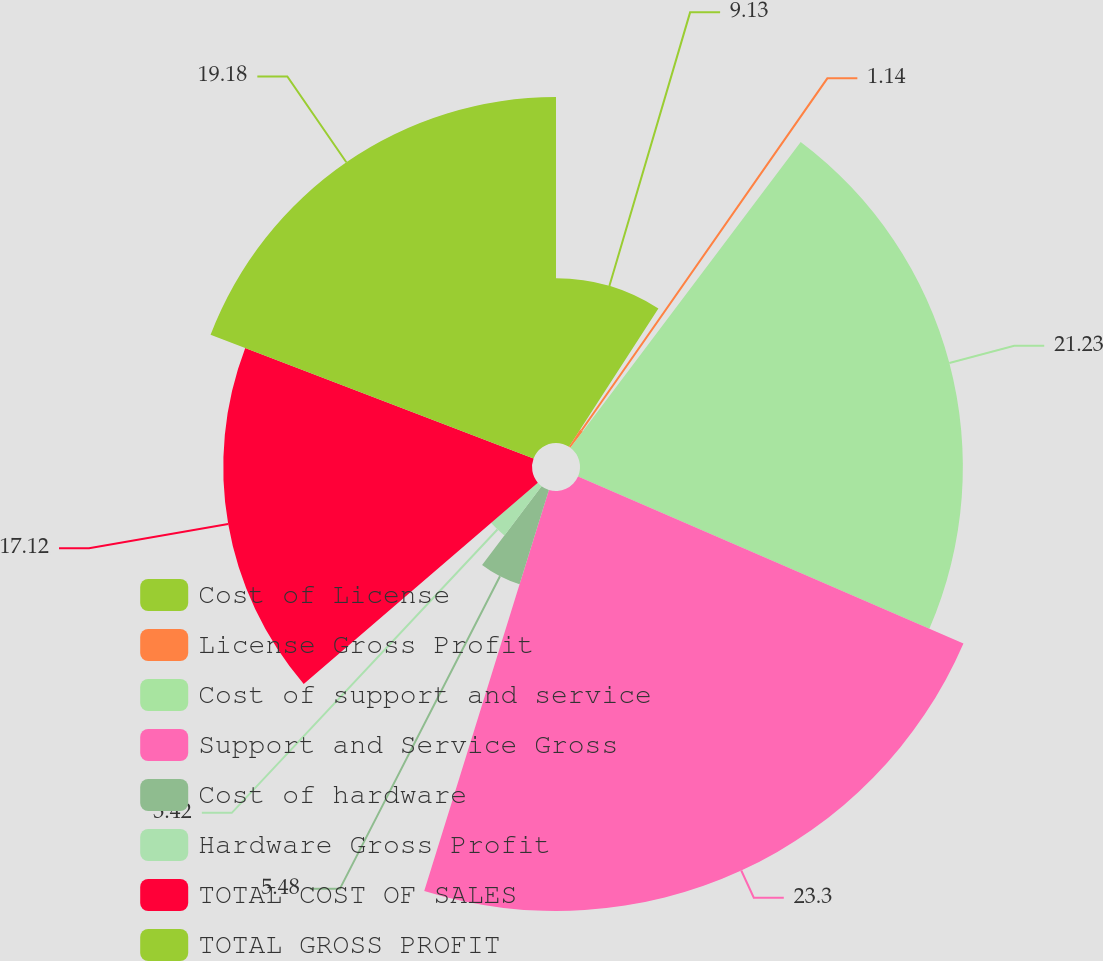<chart> <loc_0><loc_0><loc_500><loc_500><pie_chart><fcel>Cost of License<fcel>License Gross Profit<fcel>Cost of support and service<fcel>Support and Service Gross<fcel>Cost of hardware<fcel>Hardware Gross Profit<fcel>TOTAL COST OF SALES<fcel>TOTAL GROSS PROFIT<nl><fcel>9.13%<fcel>1.14%<fcel>21.23%<fcel>23.29%<fcel>5.48%<fcel>3.42%<fcel>17.12%<fcel>19.18%<nl></chart> 